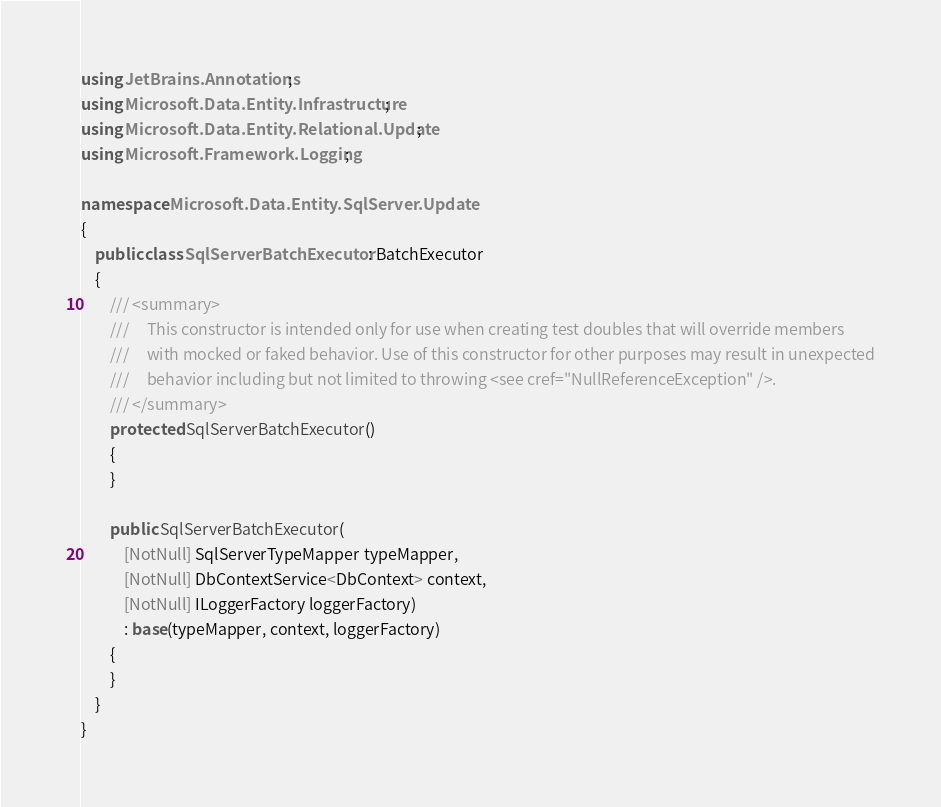Convert code to text. <code><loc_0><loc_0><loc_500><loc_500><_C#_>using JetBrains.Annotations;
using Microsoft.Data.Entity.Infrastructure;
using Microsoft.Data.Entity.Relational.Update;
using Microsoft.Framework.Logging;

namespace Microsoft.Data.Entity.SqlServer.Update
{
    public class SqlServerBatchExecutor : BatchExecutor
    {
        /// <summary>
        ///     This constructor is intended only for use when creating test doubles that will override members
        ///     with mocked or faked behavior. Use of this constructor for other purposes may result in unexpected
        ///     behavior including but not limited to throwing <see cref="NullReferenceException" />.
        /// </summary>
        protected SqlServerBatchExecutor()
        {
        }

        public SqlServerBatchExecutor(
            [NotNull] SqlServerTypeMapper typeMapper,
            [NotNull] DbContextService<DbContext> context,
            [NotNull] ILoggerFactory loggerFactory)
            : base(typeMapper, context, loggerFactory)
        {
        }
    }
}
</code> 